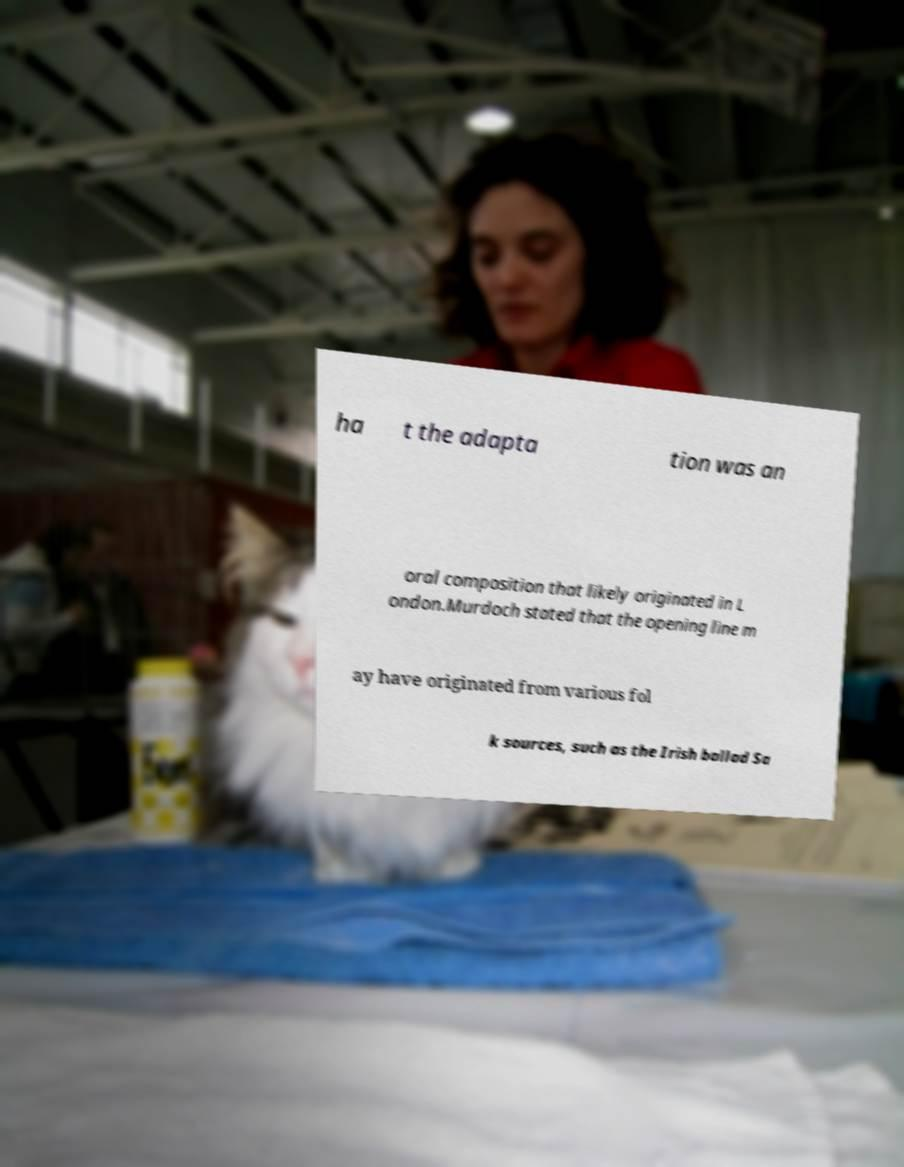For documentation purposes, I need the text within this image transcribed. Could you provide that? ha t the adapta tion was an oral composition that likely originated in L ondon.Murdoch stated that the opening line m ay have originated from various fol k sources, such as the Irish ballad Sa 